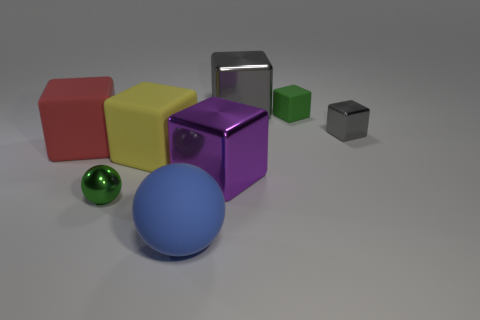Subtract all green blocks. How many blocks are left? 5 Subtract all small gray shiny blocks. How many blocks are left? 5 Subtract all blue blocks. Subtract all blue balls. How many blocks are left? 6 Add 1 tiny shiny things. How many objects exist? 9 Subtract all blocks. How many objects are left? 2 Add 3 big blue rubber balls. How many big blue rubber balls are left? 4 Add 2 big blue spheres. How many big blue spheres exist? 3 Subtract 0 blue cylinders. How many objects are left? 8 Subtract all green objects. Subtract all small cyan matte objects. How many objects are left? 6 